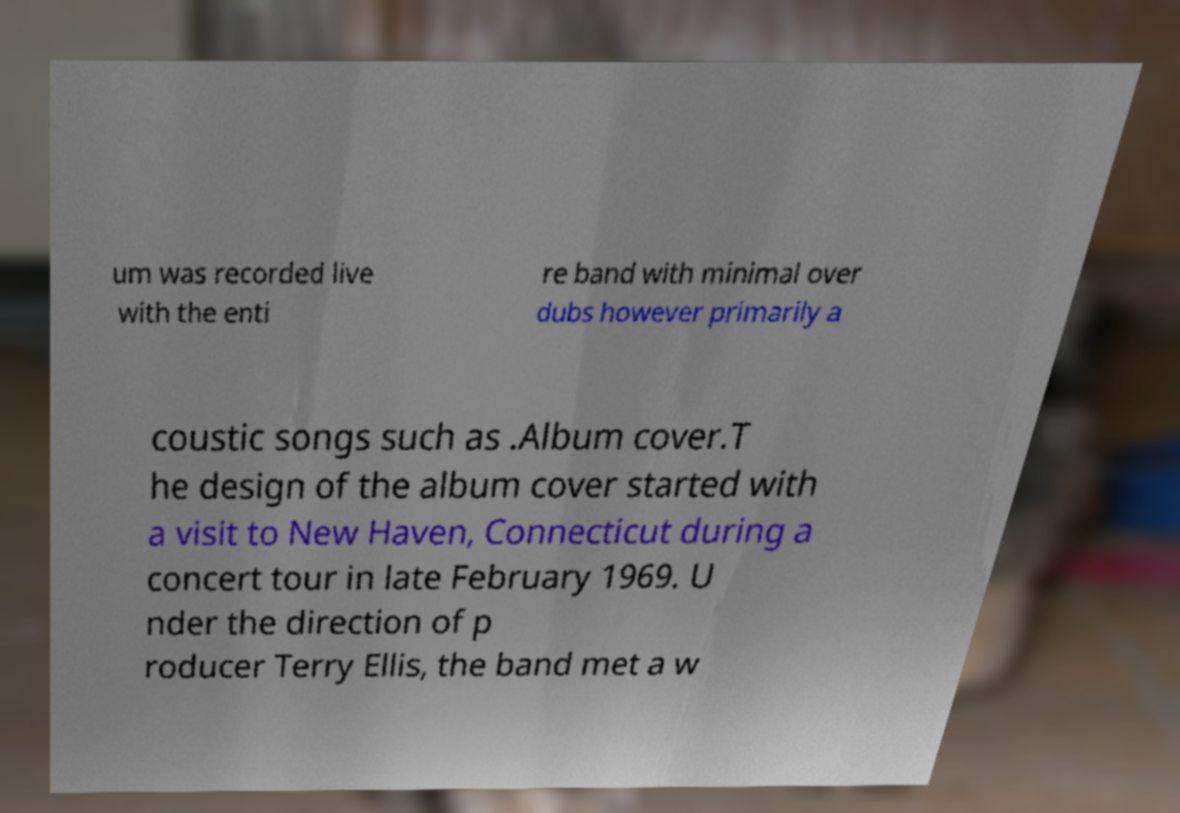Can you read and provide the text displayed in the image?This photo seems to have some interesting text. Can you extract and type it out for me? um was recorded live with the enti re band with minimal over dubs however primarily a coustic songs such as .Album cover.T he design of the album cover started with a visit to New Haven, Connecticut during a concert tour in late February 1969. U nder the direction of p roducer Terry Ellis, the band met a w 